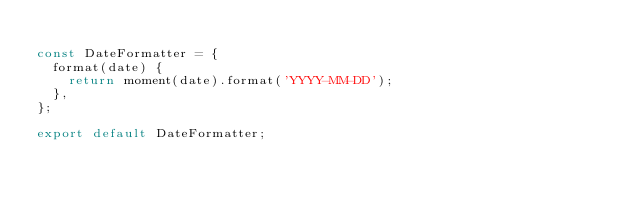<code> <loc_0><loc_0><loc_500><loc_500><_JavaScript_>
const DateFormatter = {
  format(date) {
    return moment(date).format('YYYY-MM-DD');
  },
};

export default DateFormatter;
</code> 